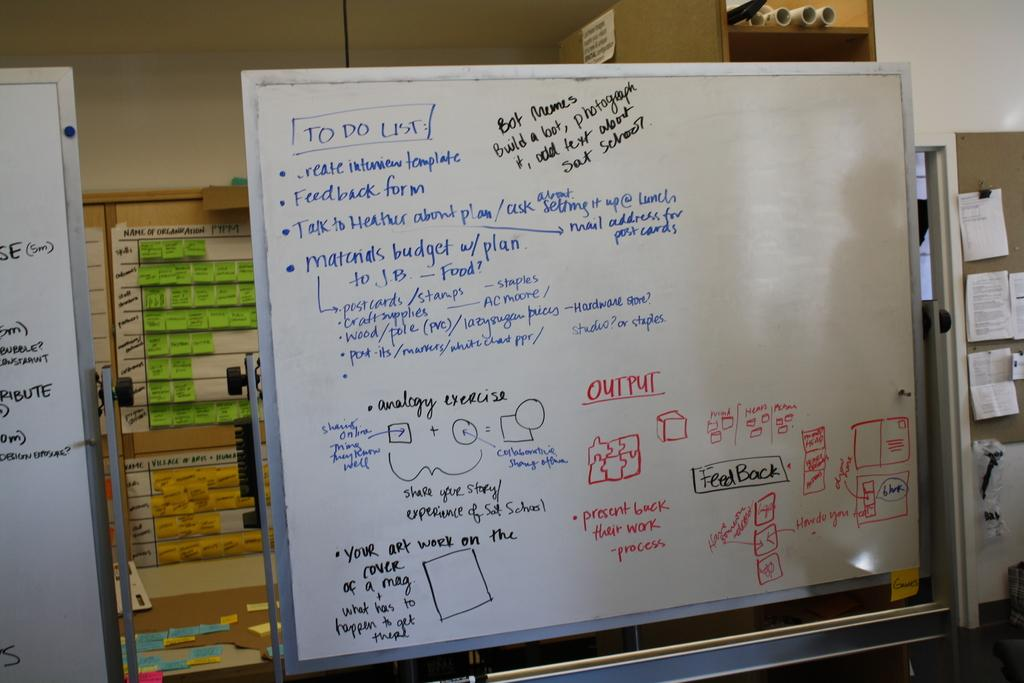<image>
Summarize the visual content of the image. Room with a white board that says "To Do List". 